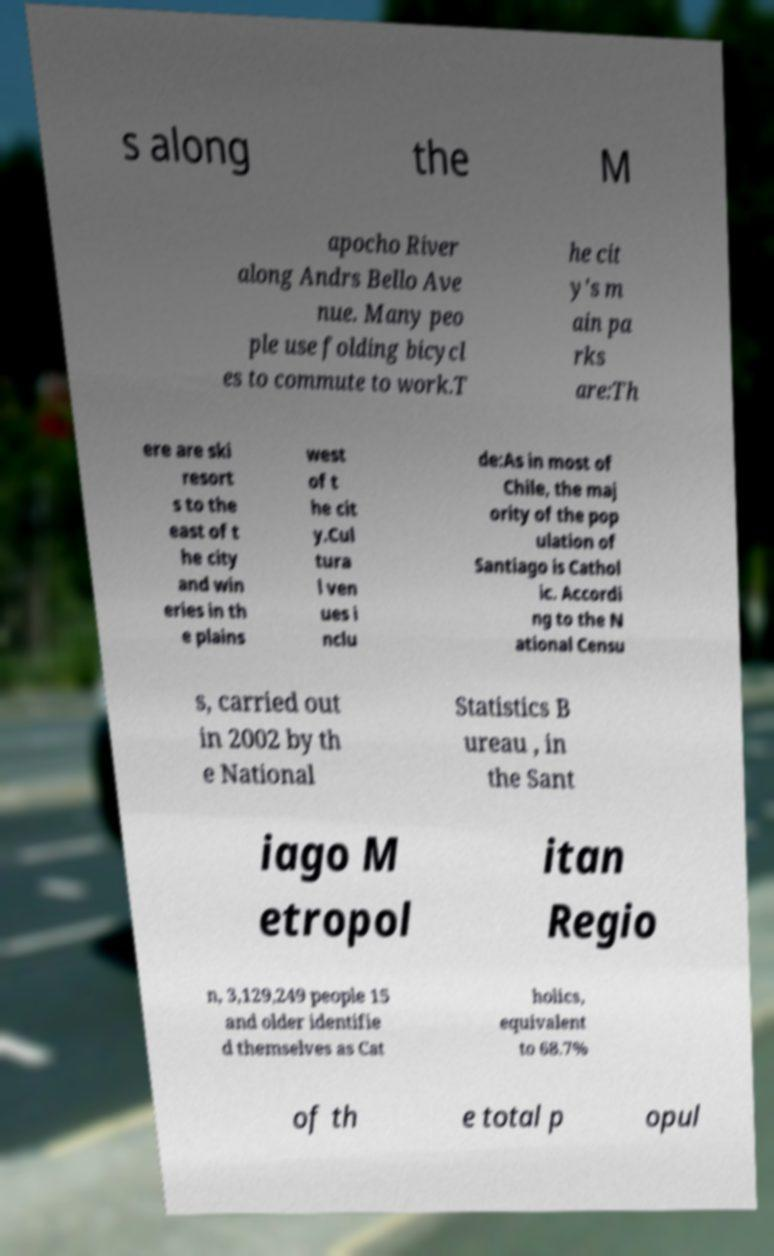Can you accurately transcribe the text from the provided image for me? s along the M apocho River along Andrs Bello Ave nue. Many peo ple use folding bicycl es to commute to work.T he cit y's m ain pa rks are:Th ere are ski resort s to the east of t he city and win eries in th e plains west of t he cit y.Cul tura l ven ues i nclu de:As in most of Chile, the maj ority of the pop ulation of Santiago is Cathol ic. Accordi ng to the N ational Censu s, carried out in 2002 by th e National Statistics B ureau , in the Sant iago M etropol itan Regio n, 3,129,249 people 15 and older identifie d themselves as Cat holics, equivalent to 68.7% of th e total p opul 